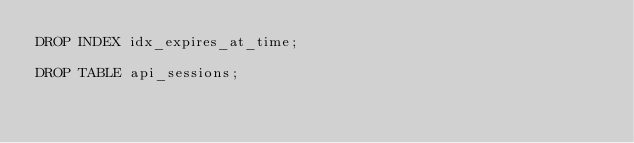<code> <loc_0><loc_0><loc_500><loc_500><_SQL_>DROP INDEX idx_expires_at_time;

DROP TABLE api_sessions;
</code> 